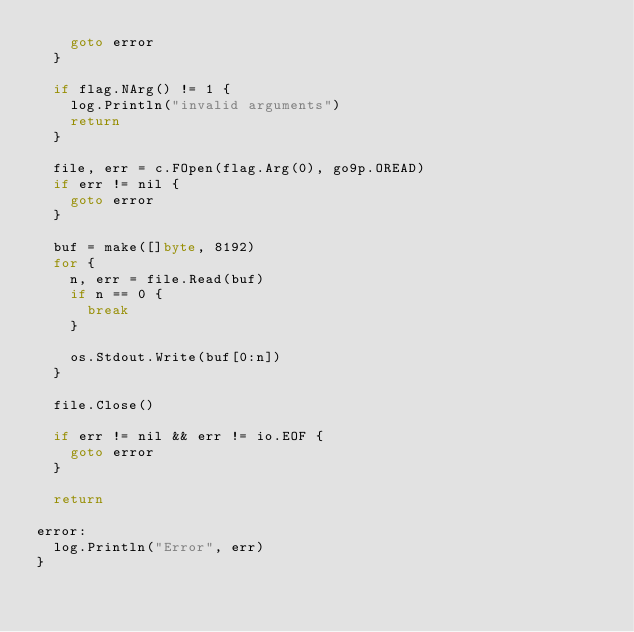Convert code to text. <code><loc_0><loc_0><loc_500><loc_500><_Go_>		goto error
	}

	if flag.NArg() != 1 {
		log.Println("invalid arguments")
		return
	}

	file, err = c.FOpen(flag.Arg(0), go9p.OREAD)
	if err != nil {
		goto error
	}

	buf = make([]byte, 8192)
	for {
		n, err = file.Read(buf)
		if n == 0 {
			break
		}

		os.Stdout.Write(buf[0:n])
	}

	file.Close()

	if err != nil && err != io.EOF {
		goto error
	}

	return

error:
	log.Println("Error", err)
}
</code> 